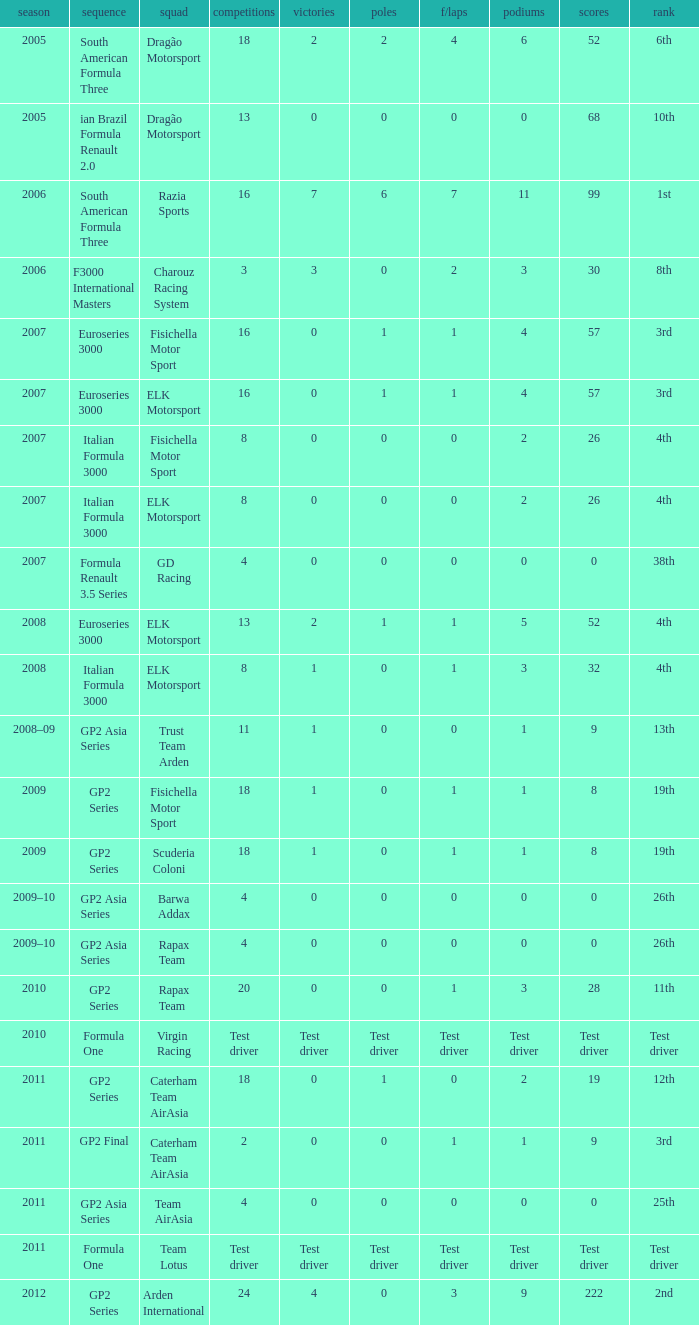What was his position in 2009 with 1 win? 19th, 19th. 